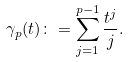<formula> <loc_0><loc_0><loc_500><loc_500>\gamma _ { p } ( t ) \colon = \sum _ { j = 1 } ^ { p - 1 } \frac { t ^ { j } } { j } .</formula> 